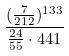Convert formula to latex. <formula><loc_0><loc_0><loc_500><loc_500>\frac { ( \frac { 7 } { 2 1 2 } ) ^ { 1 3 3 } } { \frac { 2 4 } { 5 5 } \cdot 4 4 1 }</formula> 